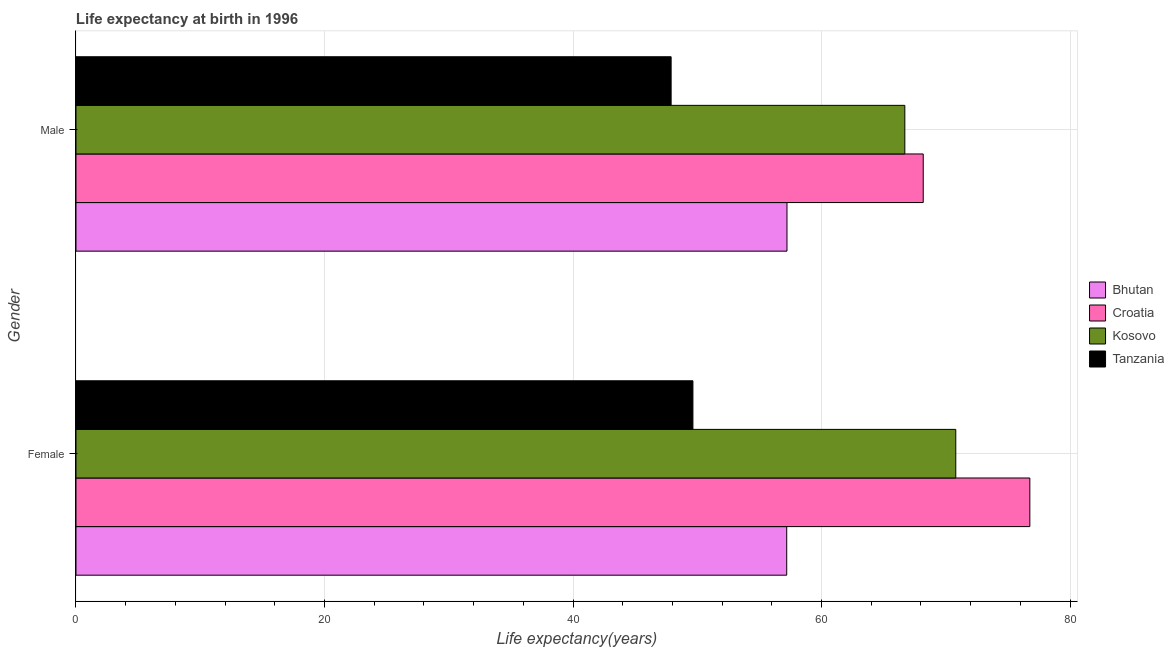How many different coloured bars are there?
Your answer should be very brief. 4. Are the number of bars per tick equal to the number of legend labels?
Your response must be concise. Yes. How many bars are there on the 2nd tick from the top?
Your answer should be compact. 4. How many bars are there on the 2nd tick from the bottom?
Your answer should be compact. 4. What is the label of the 1st group of bars from the top?
Provide a succinct answer. Male. What is the life expectancy(male) in Bhutan?
Offer a very short reply. 57.22. Across all countries, what is the maximum life expectancy(male)?
Provide a short and direct response. 68.18. Across all countries, what is the minimum life expectancy(female)?
Make the answer very short. 49.65. In which country was the life expectancy(male) maximum?
Offer a terse response. Croatia. In which country was the life expectancy(male) minimum?
Offer a terse response. Tanzania. What is the total life expectancy(female) in the graph?
Make the answer very short. 254.4. What is the difference between the life expectancy(male) in Tanzania and that in Bhutan?
Provide a succinct answer. -9.32. What is the difference between the life expectancy(female) in Croatia and the life expectancy(male) in Tanzania?
Your answer should be very brief. 28.87. What is the average life expectancy(male) per country?
Keep it short and to the point. 60. What is the difference between the life expectancy(male) and life expectancy(female) in Tanzania?
Your answer should be very brief. -1.75. In how many countries, is the life expectancy(female) greater than 72 years?
Give a very brief answer. 1. What is the ratio of the life expectancy(male) in Bhutan to that in Kosovo?
Your response must be concise. 0.86. Is the life expectancy(female) in Tanzania less than that in Bhutan?
Offer a very short reply. Yes. What does the 3rd bar from the top in Female represents?
Offer a terse response. Croatia. What does the 3rd bar from the bottom in Male represents?
Give a very brief answer. Kosovo. How many bars are there?
Offer a terse response. 8. Are all the bars in the graph horizontal?
Offer a terse response. Yes. How many countries are there in the graph?
Provide a succinct answer. 4. Are the values on the major ticks of X-axis written in scientific E-notation?
Make the answer very short. No. Does the graph contain grids?
Give a very brief answer. Yes. Where does the legend appear in the graph?
Your answer should be very brief. Center right. What is the title of the graph?
Ensure brevity in your answer.  Life expectancy at birth in 1996. Does "East Asia (all income levels)" appear as one of the legend labels in the graph?
Provide a succinct answer. No. What is the label or title of the X-axis?
Your response must be concise. Life expectancy(years). What is the label or title of the Y-axis?
Ensure brevity in your answer.  Gender. What is the Life expectancy(years) in Bhutan in Female?
Provide a succinct answer. 57.2. What is the Life expectancy(years) in Croatia in Female?
Provide a short and direct response. 76.76. What is the Life expectancy(years) in Kosovo in Female?
Keep it short and to the point. 70.8. What is the Life expectancy(years) in Tanzania in Female?
Give a very brief answer. 49.65. What is the Life expectancy(years) in Bhutan in Male?
Provide a succinct answer. 57.22. What is the Life expectancy(years) of Croatia in Male?
Offer a terse response. 68.18. What is the Life expectancy(years) of Kosovo in Male?
Keep it short and to the point. 66.7. What is the Life expectancy(years) in Tanzania in Male?
Keep it short and to the point. 47.89. Across all Gender, what is the maximum Life expectancy(years) in Bhutan?
Offer a very short reply. 57.22. Across all Gender, what is the maximum Life expectancy(years) in Croatia?
Ensure brevity in your answer.  76.76. Across all Gender, what is the maximum Life expectancy(years) in Kosovo?
Offer a very short reply. 70.8. Across all Gender, what is the maximum Life expectancy(years) of Tanzania?
Make the answer very short. 49.65. Across all Gender, what is the minimum Life expectancy(years) of Bhutan?
Offer a very short reply. 57.2. Across all Gender, what is the minimum Life expectancy(years) of Croatia?
Offer a terse response. 68.18. Across all Gender, what is the minimum Life expectancy(years) in Kosovo?
Your response must be concise. 66.7. Across all Gender, what is the minimum Life expectancy(years) of Tanzania?
Make the answer very short. 47.89. What is the total Life expectancy(years) in Bhutan in the graph?
Offer a very short reply. 114.41. What is the total Life expectancy(years) of Croatia in the graph?
Keep it short and to the point. 144.94. What is the total Life expectancy(years) of Kosovo in the graph?
Offer a terse response. 137.5. What is the total Life expectancy(years) in Tanzania in the graph?
Your answer should be compact. 97.54. What is the difference between the Life expectancy(years) of Bhutan in Female and that in Male?
Provide a succinct answer. -0.02. What is the difference between the Life expectancy(years) of Croatia in Female and that in Male?
Give a very brief answer. 8.58. What is the difference between the Life expectancy(years) in Kosovo in Female and that in Male?
Give a very brief answer. 4.1. What is the difference between the Life expectancy(years) in Tanzania in Female and that in Male?
Make the answer very short. 1.75. What is the difference between the Life expectancy(years) of Bhutan in Female and the Life expectancy(years) of Croatia in Male?
Provide a short and direct response. -10.98. What is the difference between the Life expectancy(years) of Bhutan in Female and the Life expectancy(years) of Kosovo in Male?
Provide a short and direct response. -9.51. What is the difference between the Life expectancy(years) in Bhutan in Female and the Life expectancy(years) in Tanzania in Male?
Your answer should be compact. 9.3. What is the difference between the Life expectancy(years) of Croatia in Female and the Life expectancy(years) of Kosovo in Male?
Provide a succinct answer. 10.06. What is the difference between the Life expectancy(years) of Croatia in Female and the Life expectancy(years) of Tanzania in Male?
Give a very brief answer. 28.87. What is the difference between the Life expectancy(years) in Kosovo in Female and the Life expectancy(years) in Tanzania in Male?
Offer a terse response. 22.91. What is the average Life expectancy(years) in Bhutan per Gender?
Make the answer very short. 57.21. What is the average Life expectancy(years) of Croatia per Gender?
Ensure brevity in your answer.  72.47. What is the average Life expectancy(years) in Kosovo per Gender?
Your answer should be very brief. 68.75. What is the average Life expectancy(years) in Tanzania per Gender?
Provide a succinct answer. 48.77. What is the difference between the Life expectancy(years) in Bhutan and Life expectancy(years) in Croatia in Female?
Give a very brief answer. -19.57. What is the difference between the Life expectancy(years) of Bhutan and Life expectancy(years) of Kosovo in Female?
Your answer should be very brief. -13.61. What is the difference between the Life expectancy(years) of Bhutan and Life expectancy(years) of Tanzania in Female?
Ensure brevity in your answer.  7.55. What is the difference between the Life expectancy(years) of Croatia and Life expectancy(years) of Kosovo in Female?
Your answer should be very brief. 5.96. What is the difference between the Life expectancy(years) of Croatia and Life expectancy(years) of Tanzania in Female?
Your response must be concise. 27.11. What is the difference between the Life expectancy(years) in Kosovo and Life expectancy(years) in Tanzania in Female?
Your response must be concise. 21.15. What is the difference between the Life expectancy(years) of Bhutan and Life expectancy(years) of Croatia in Male?
Your answer should be very brief. -10.96. What is the difference between the Life expectancy(years) in Bhutan and Life expectancy(years) in Kosovo in Male?
Your answer should be compact. -9.48. What is the difference between the Life expectancy(years) in Bhutan and Life expectancy(years) in Tanzania in Male?
Your answer should be compact. 9.32. What is the difference between the Life expectancy(years) in Croatia and Life expectancy(years) in Kosovo in Male?
Give a very brief answer. 1.48. What is the difference between the Life expectancy(years) in Croatia and Life expectancy(years) in Tanzania in Male?
Make the answer very short. 20.29. What is the difference between the Life expectancy(years) in Kosovo and Life expectancy(years) in Tanzania in Male?
Provide a short and direct response. 18.81. What is the ratio of the Life expectancy(years) in Croatia in Female to that in Male?
Your answer should be very brief. 1.13. What is the ratio of the Life expectancy(years) of Kosovo in Female to that in Male?
Your response must be concise. 1.06. What is the ratio of the Life expectancy(years) in Tanzania in Female to that in Male?
Your answer should be very brief. 1.04. What is the difference between the highest and the second highest Life expectancy(years) of Bhutan?
Give a very brief answer. 0.02. What is the difference between the highest and the second highest Life expectancy(years) in Croatia?
Offer a terse response. 8.58. What is the difference between the highest and the second highest Life expectancy(years) in Kosovo?
Offer a terse response. 4.1. What is the difference between the highest and the second highest Life expectancy(years) of Tanzania?
Your answer should be very brief. 1.75. What is the difference between the highest and the lowest Life expectancy(years) of Bhutan?
Offer a very short reply. 0.02. What is the difference between the highest and the lowest Life expectancy(years) in Croatia?
Ensure brevity in your answer.  8.58. What is the difference between the highest and the lowest Life expectancy(years) in Tanzania?
Make the answer very short. 1.75. 